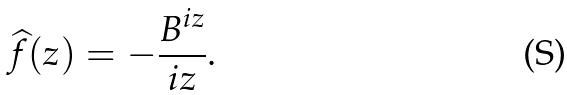Convert formula to latex. <formula><loc_0><loc_0><loc_500><loc_500>\widehat { f } ( z ) = - \frac { B ^ { i z } } { i z } .</formula> 